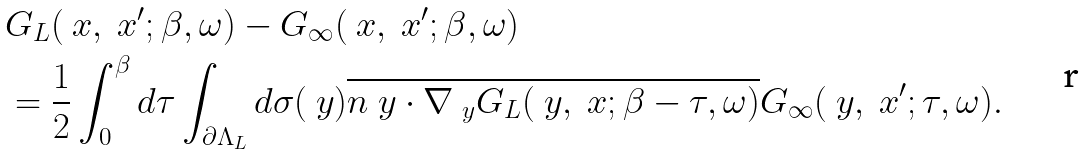Convert formula to latex. <formula><loc_0><loc_0><loc_500><loc_500>& G _ { L } ( \ x , \ x ^ { \prime } ; \beta , \omega ) - G _ { \infty } ( \ x , \ x ^ { \prime } ; \beta , \omega ) \\ & = \frac { 1 } { 2 } \int _ { 0 } ^ { \beta } d \tau \int _ { \partial \Lambda _ { L } } d \sigma ( \ y ) \overline { { n } _ { \ } y \cdot \nabla _ { \ y } G _ { L } ( \ y , \ x ; \beta - \tau , \omega ) } G _ { \infty } ( \ y , \ x ^ { \prime } ; \tau , \omega ) .</formula> 